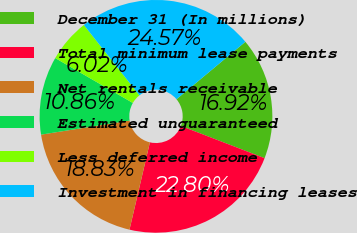Convert chart. <chart><loc_0><loc_0><loc_500><loc_500><pie_chart><fcel>December 31 (In millions)<fcel>Total minimum lease payments<fcel>Net rentals receivable<fcel>Estimated unguaranteed<fcel>Less deferred income<fcel>Investment in financing leases<nl><fcel>16.92%<fcel>22.8%<fcel>18.83%<fcel>10.86%<fcel>6.02%<fcel>24.57%<nl></chart> 